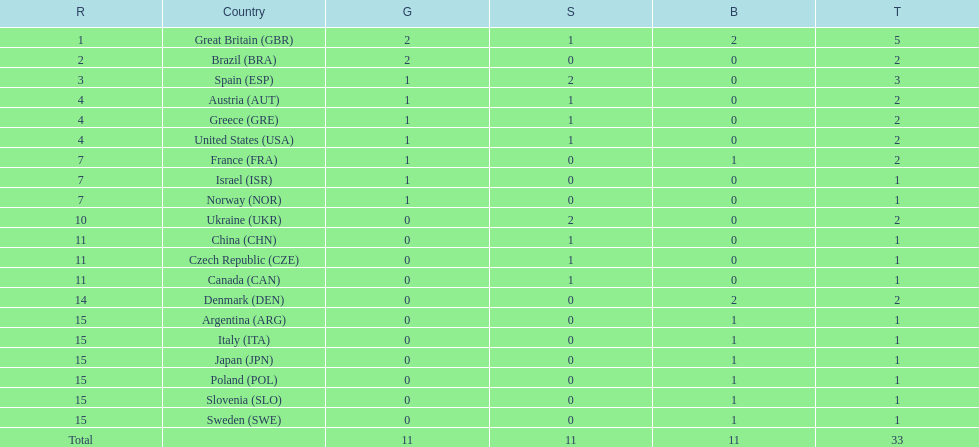Which country won the most medals total? Great Britain (GBR). 